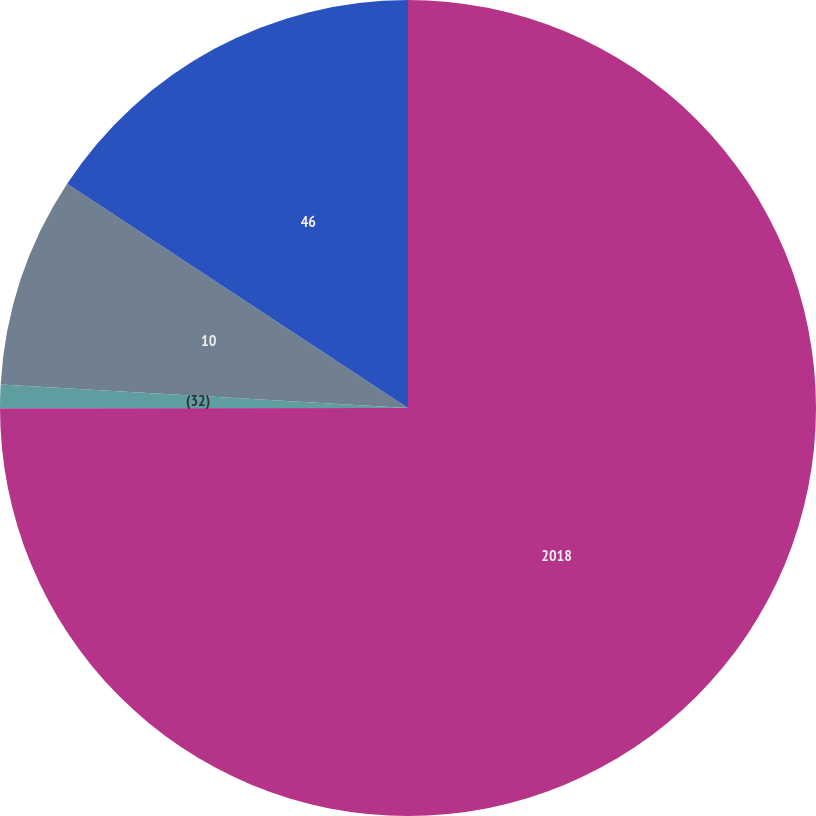Convert chart. <chart><loc_0><loc_0><loc_500><loc_500><pie_chart><fcel>2018<fcel>(32)<fcel>10<fcel>46<nl><fcel>74.99%<fcel>0.93%<fcel>8.34%<fcel>15.74%<nl></chart> 